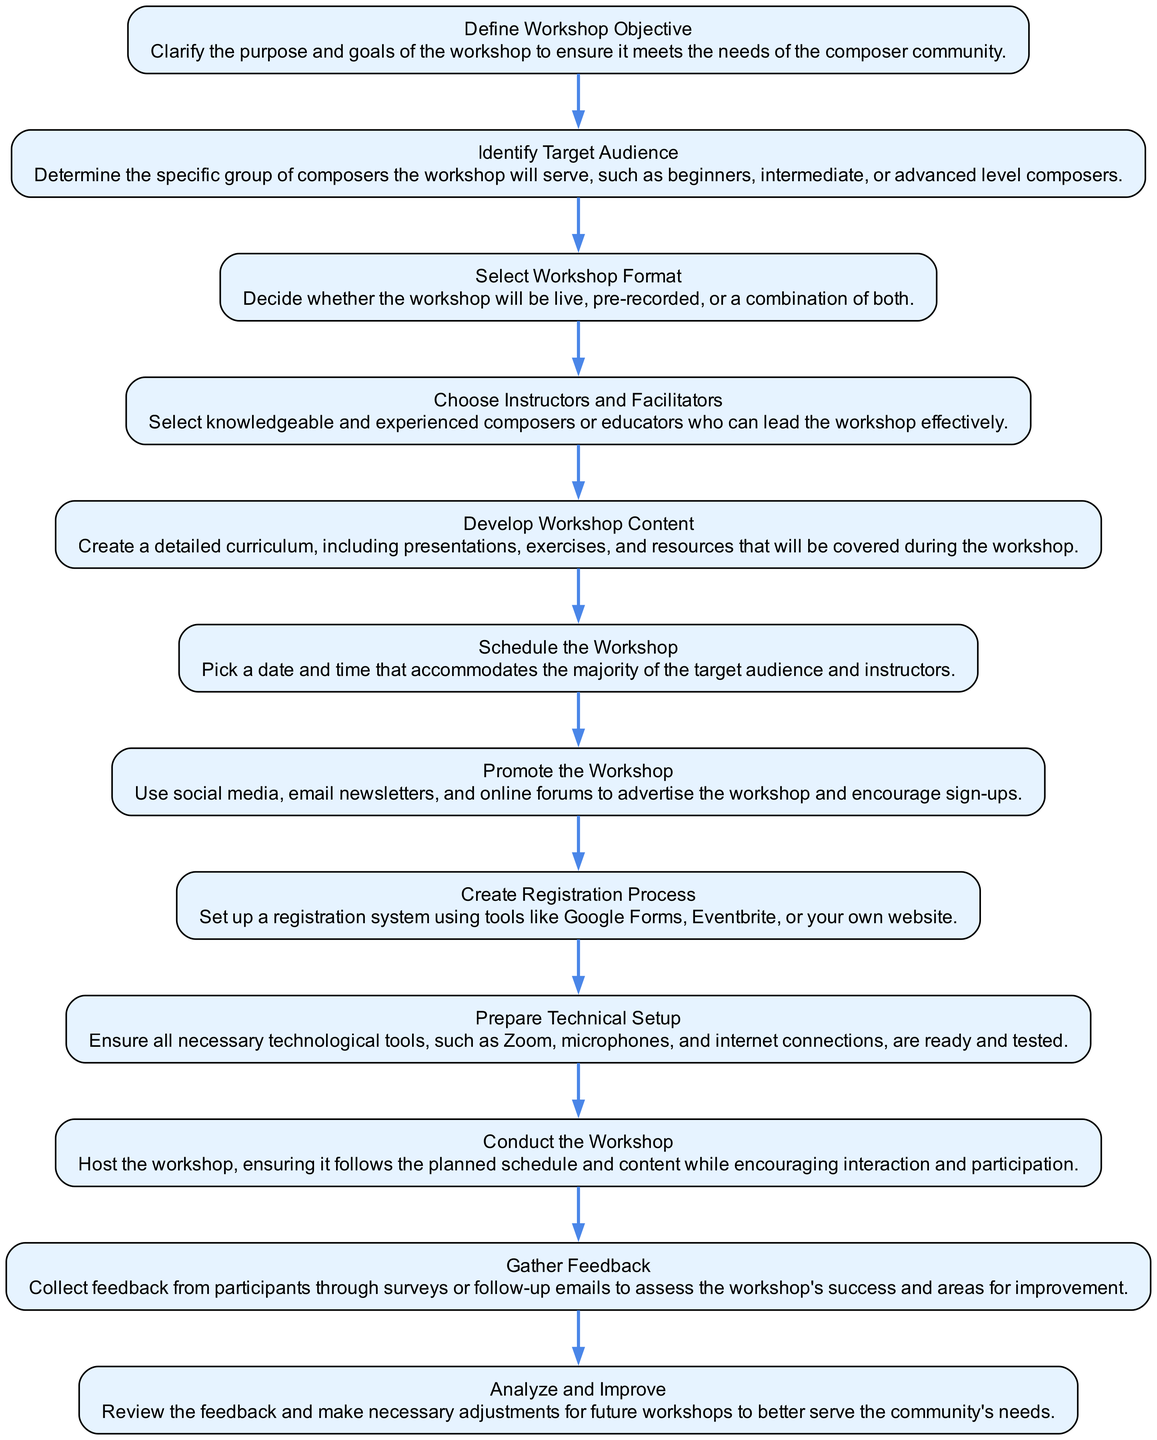What's the first step in the diagram? The first step listed in the diagram is "Define Workshop Objective." This is the starting point of the flow and can be found at the top of the diagram.
Answer: Define Workshop Objective How many total steps are in the diagram? The diagram lists a total of 12 steps, which are sequentially arranged to outline the process of organizing an online workshop.
Answer: 12 What is the last step in the flow chart? The last step in the diagram is "Analyze and Improve." This step comes last as it involves reviewing feedback and making adjustments for future workshops.
Answer: Analyze and Improve Which step involves advertising the workshop? The step that involves advertising the workshop is "Promote the Workshop," which comes after "Schedule the Workshop" in the flow.
Answer: Promote the Workshop What step follows "Create Registration Process"? The step that follows "Create Registration Process" is "Prepare Technical Setup." This means after the registration is established, the next focus is on the technical aspects needed for the workshop.
Answer: Prepare Technical Setup What is the purpose of the "Gather Feedback" step? "Gather Feedback" serves to collect participant responses after the workshop, which is essential for assessing its success and improving future events.
Answer: To assess success What is a crucial element to decide in the "Select Workshop Format" step? A crucial element in this step is deciding whether the workshop will be live, pre-recorded, or a combination of both. This decision impacts how the content is delivered.
Answer: Live, pre-recorded, or combination Describe the step that comes before "Conduct the Workshop." Before "Conduct the Workshop," the step is "Prepare Technical Setup." This preparation ensures all technological tools necessary for effective hosting are in place.
Answer: Prepare Technical Setup Which step requires determining the specific group of composers? The step that requires determining the specific group of composers is "Identify Target Audience," which is essential for tailoring the workshop content appropriately.
Answer: Identify Target Audience 